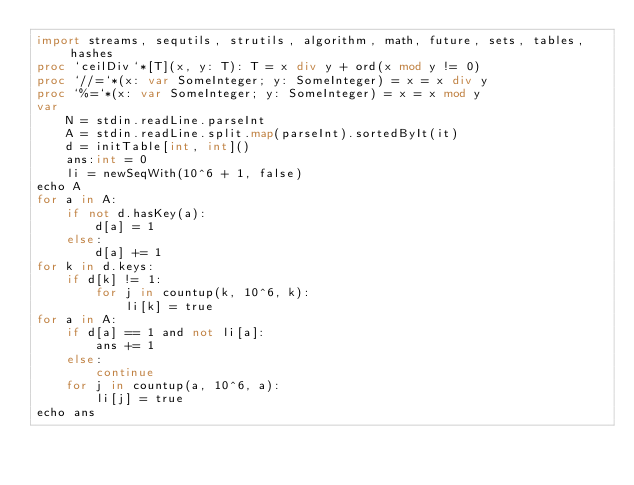Convert code to text. <code><loc_0><loc_0><loc_500><loc_500><_Nim_>import streams, sequtils, strutils, algorithm, math, future, sets, tables, hashes
proc `ceilDiv`*[T](x, y: T): T = x div y + ord(x mod y != 0)
proc `//=`*(x: var SomeInteger; y: SomeInteger) = x = x div y
proc `%=`*(x: var SomeInteger; y: SomeInteger) = x = x mod y
var
    N = stdin.readLine.parseInt
    A = stdin.readLine.split.map(parseInt).sortedByIt(it)
    d = initTable[int, int]()
    ans:int = 0
    li = newSeqWith(10^6 + 1, false)
echo A
for a in A:
    if not d.hasKey(a):
        d[a] = 1
    else:
        d[a] += 1
for k in d.keys:
    if d[k] != 1:
        for j in countup(k, 10^6, k):
            li[k] = true
for a in A:
    if d[a] == 1 and not li[a]:
        ans += 1
    else:
        continue
    for j in countup(a, 10^6, a):
        li[j] = true
echo ans</code> 